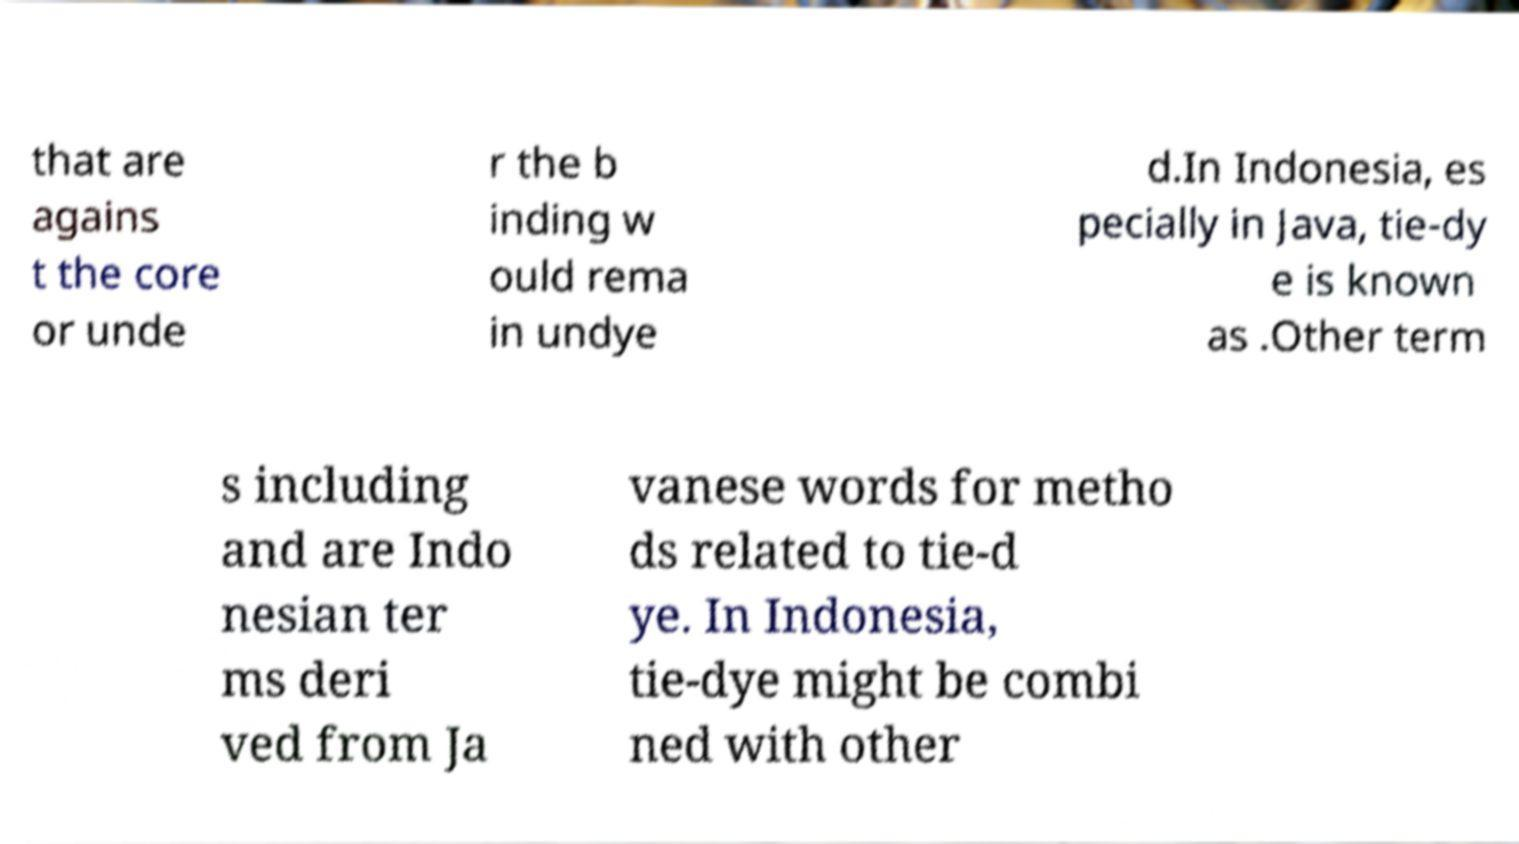Please read and relay the text visible in this image. What does it say? that are agains t the core or unde r the b inding w ould rema in undye d.In Indonesia, es pecially in Java, tie-dy e is known as .Other term s including and are Indo nesian ter ms deri ved from Ja vanese words for metho ds related to tie-d ye. In Indonesia, tie-dye might be combi ned with other 